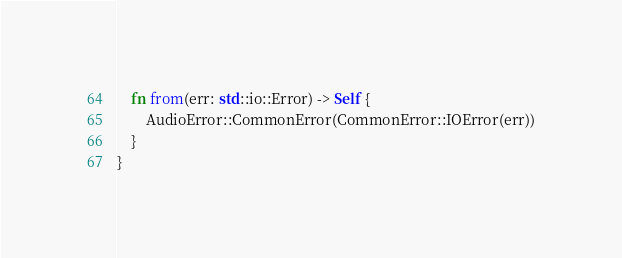Convert code to text. <code><loc_0><loc_0><loc_500><loc_500><_Rust_>    fn from(err: std::io::Error) -> Self {
        AudioError::CommonError(CommonError::IOError(err))
    }
}
</code> 